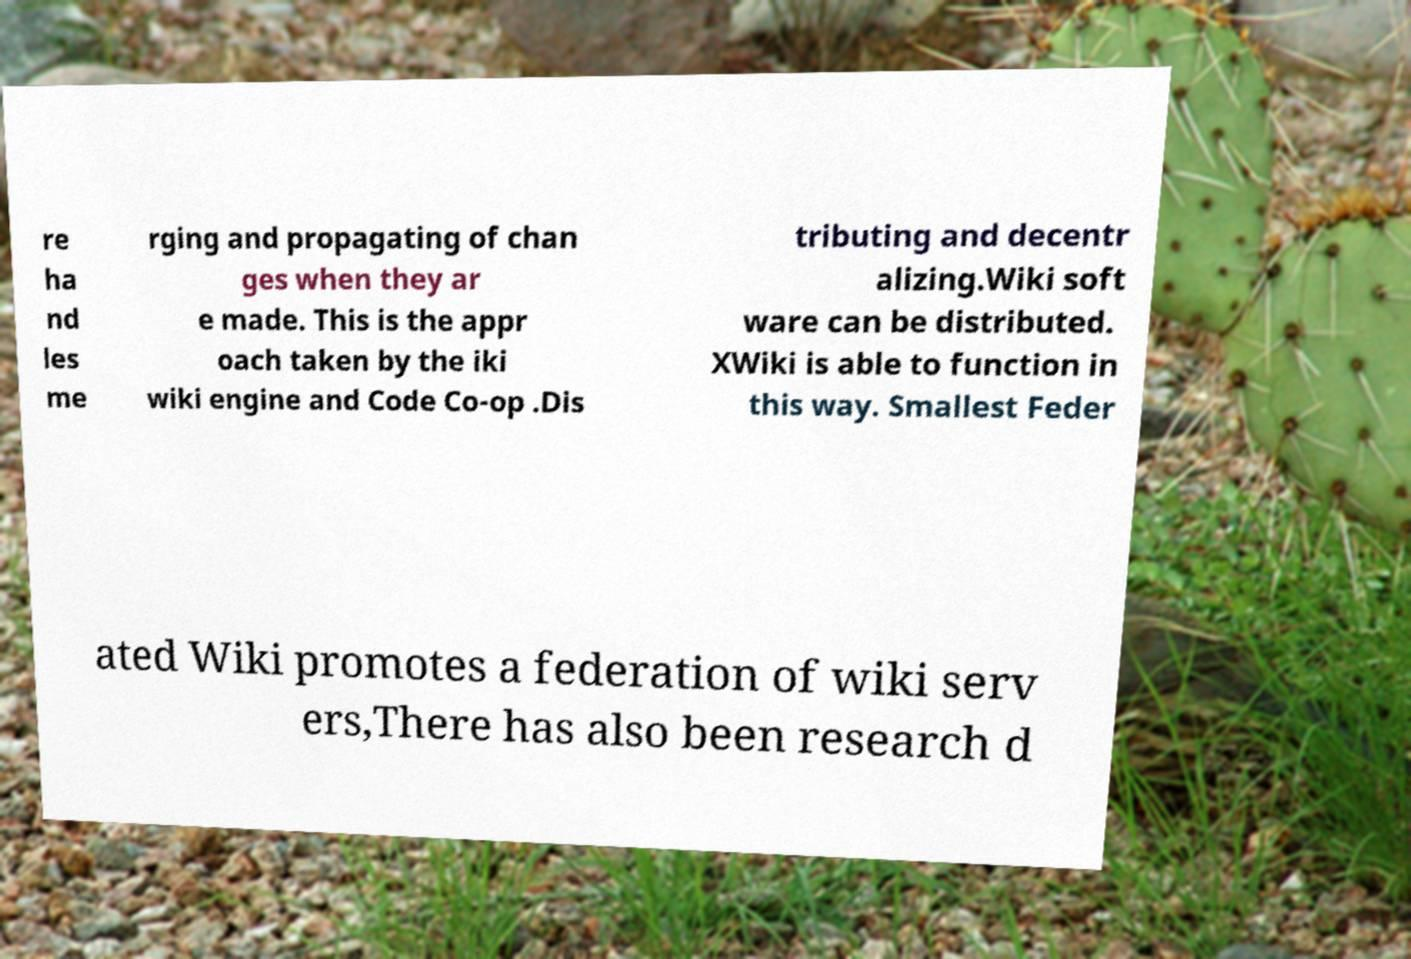I need the written content from this picture converted into text. Can you do that? re ha nd les me rging and propagating of chan ges when they ar e made. This is the appr oach taken by the iki wiki engine and Code Co-op .Dis tributing and decentr alizing.Wiki soft ware can be distributed. XWiki is able to function in this way. Smallest Feder ated Wiki promotes a federation of wiki serv ers,There has also been research d 